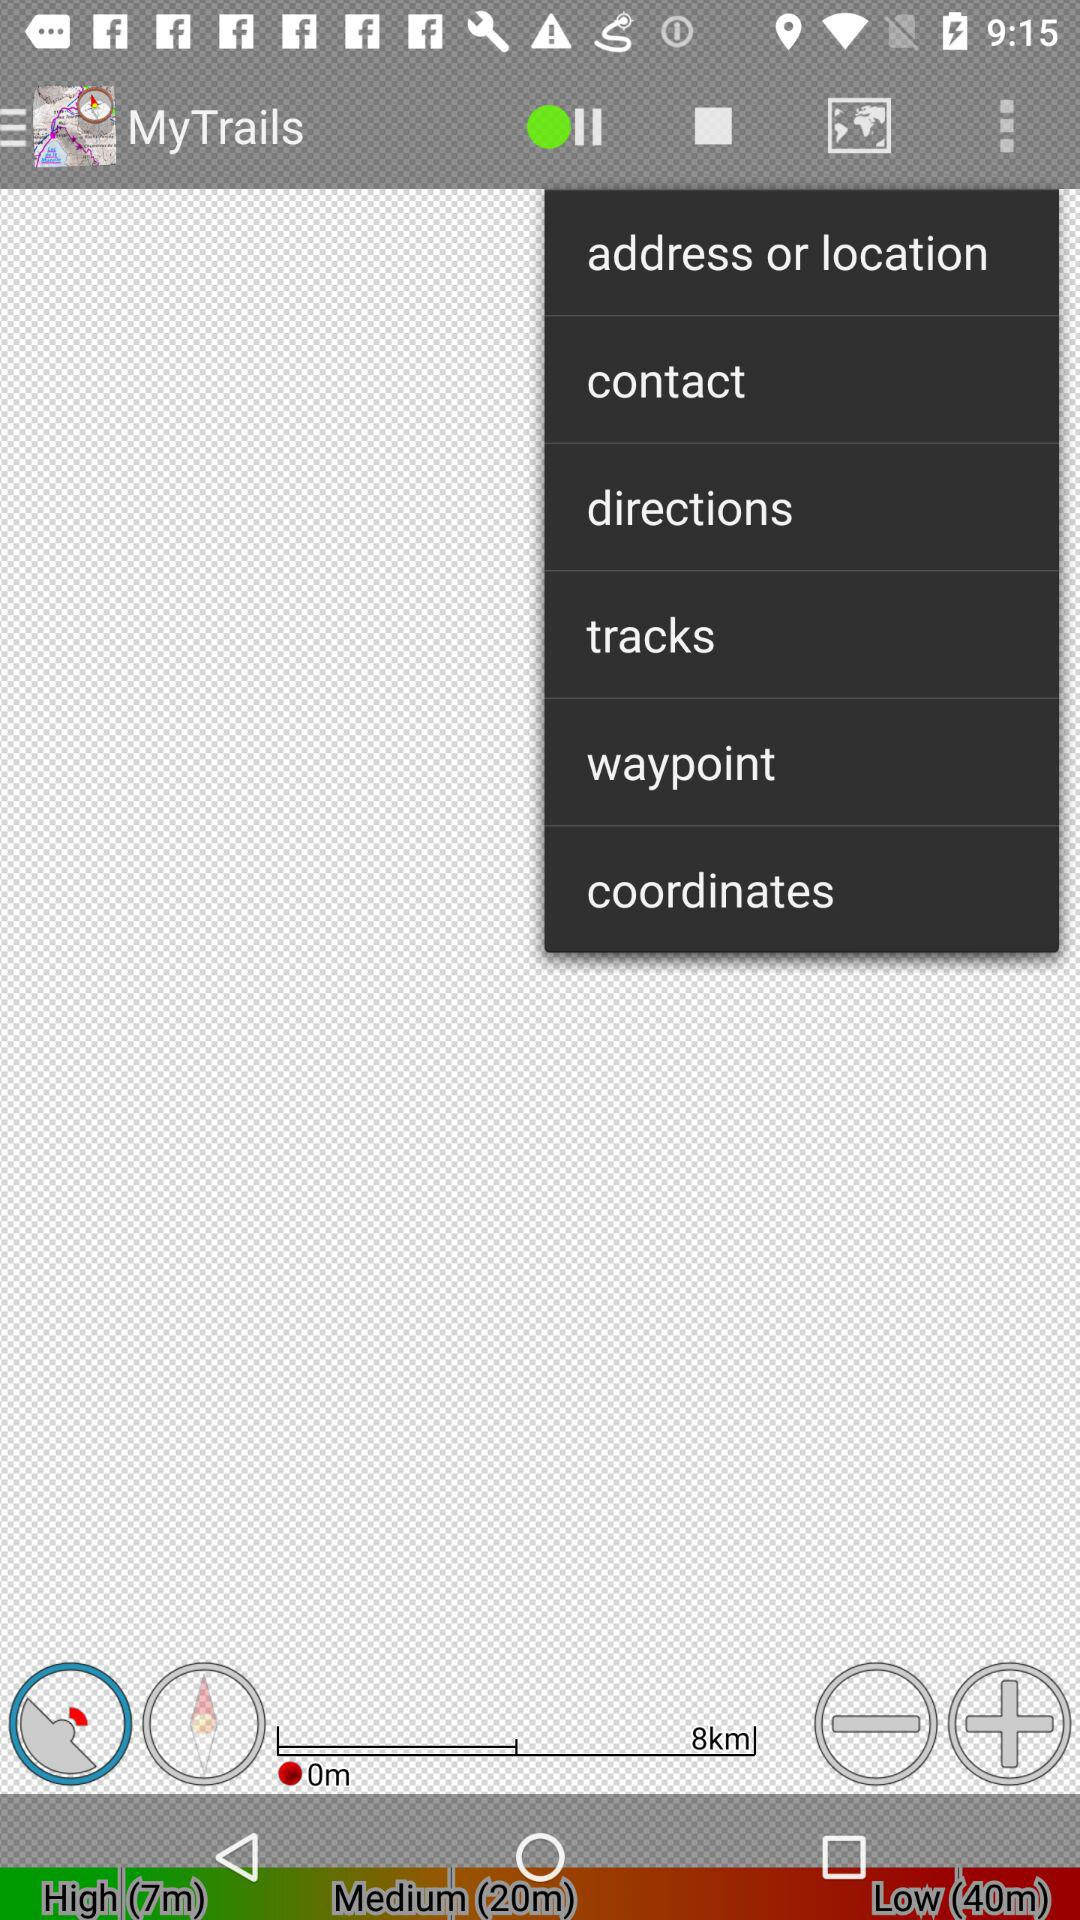What is the name of the application? The name of the application is "My Trails". 